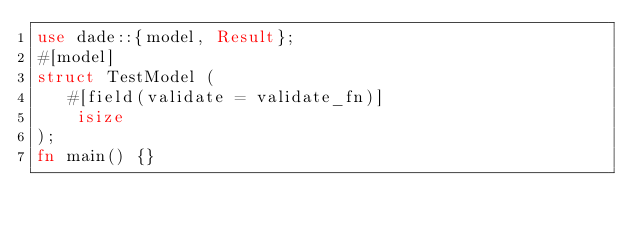<code> <loc_0><loc_0><loc_500><loc_500><_Rust_>use dade::{model, Result};
#[model]
struct TestModel (
   #[field(validate = validate_fn)]
    isize
);
fn main() {}
</code> 